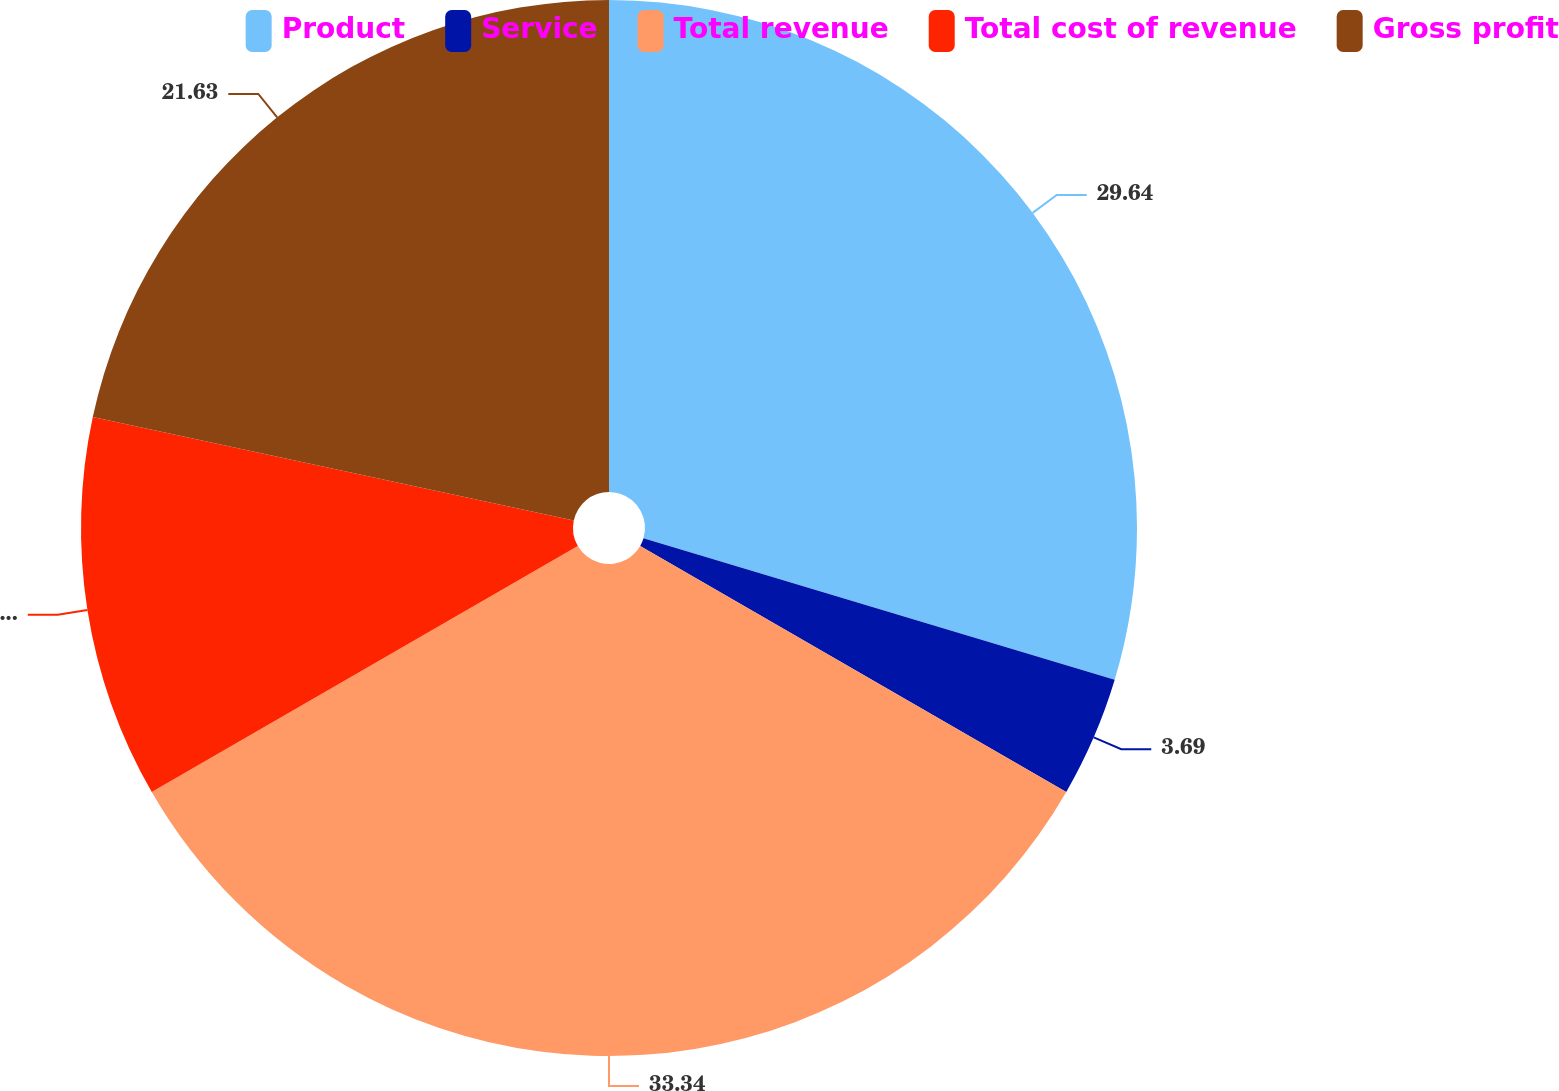<chart> <loc_0><loc_0><loc_500><loc_500><pie_chart><fcel>Product<fcel>Service<fcel>Total revenue<fcel>Total cost of revenue<fcel>Gross profit<nl><fcel>29.64%<fcel>3.69%<fcel>33.33%<fcel>11.7%<fcel>21.63%<nl></chart> 